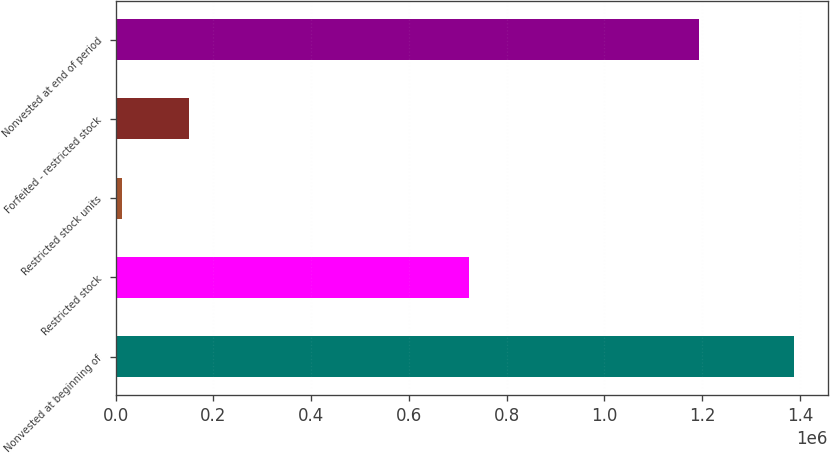Convert chart. <chart><loc_0><loc_0><loc_500><loc_500><bar_chart><fcel>Nonvested at beginning of<fcel>Restricted stock<fcel>Restricted stock units<fcel>Forfeited - restricted stock<fcel>Nonvested at end of period<nl><fcel>1.3876e+06<fcel>722215<fcel>12388<fcel>149909<fcel>1.19327e+06<nl></chart> 